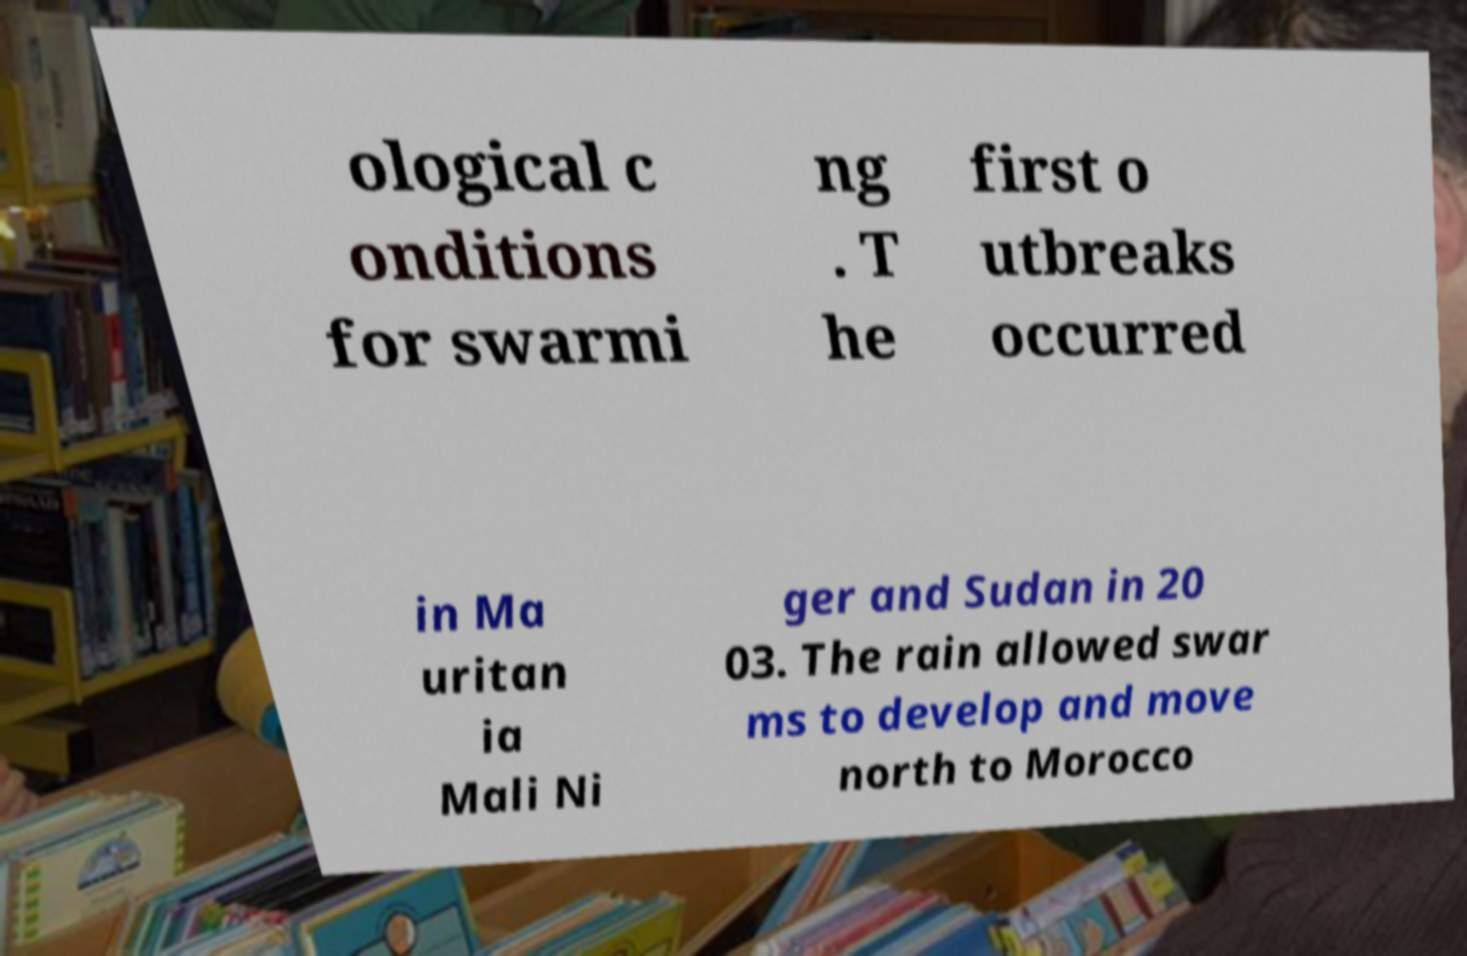Can you accurately transcribe the text from the provided image for me? ological c onditions for swarmi ng . T he first o utbreaks occurred in Ma uritan ia Mali Ni ger and Sudan in 20 03. The rain allowed swar ms to develop and move north to Morocco 